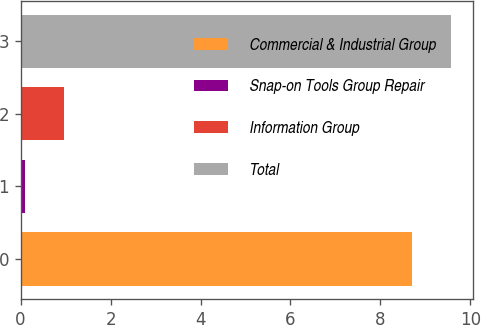Convert chart to OTSL. <chart><loc_0><loc_0><loc_500><loc_500><bar_chart><fcel>Commercial & Industrial Group<fcel>Snap-on Tools Group Repair<fcel>Information Group<fcel>Total<nl><fcel>8.7<fcel>0.1<fcel>0.97<fcel>9.57<nl></chart> 